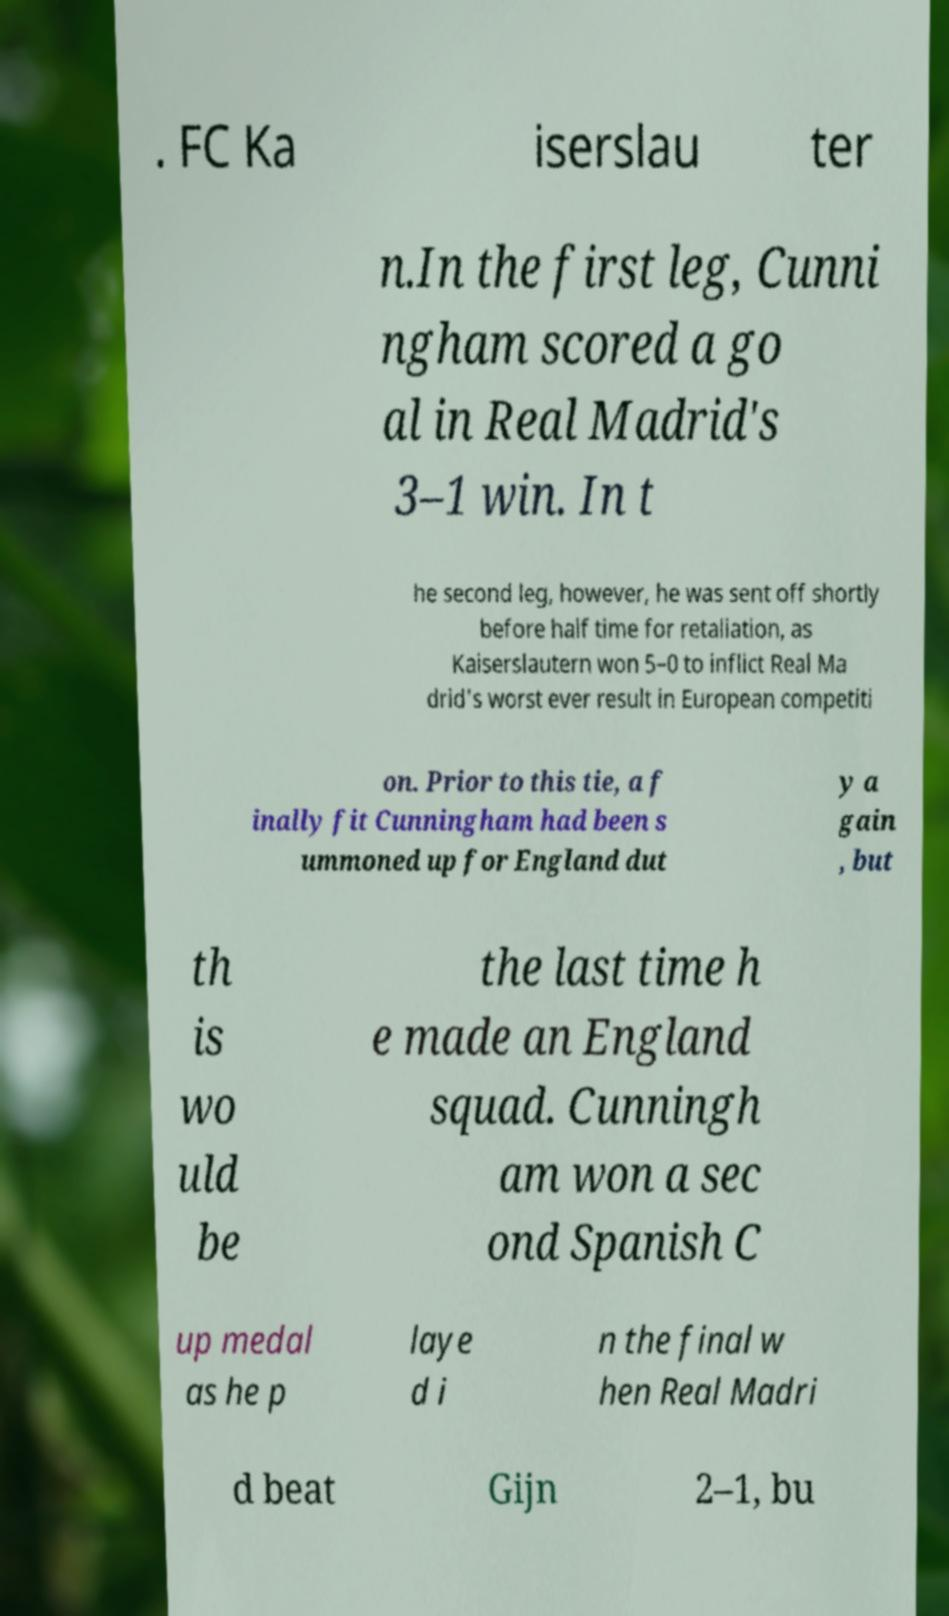Could you extract and type out the text from this image? . FC Ka iserslau ter n.In the first leg, Cunni ngham scored a go al in Real Madrid's 3–1 win. In t he second leg, however, he was sent off shortly before half time for retaliation, as Kaiserslautern won 5–0 to inflict Real Ma drid's worst ever result in European competiti on. Prior to this tie, a f inally fit Cunningham had been s ummoned up for England dut y a gain , but th is wo uld be the last time h e made an England squad. Cunningh am won a sec ond Spanish C up medal as he p laye d i n the final w hen Real Madri d beat Gijn 2–1, bu 